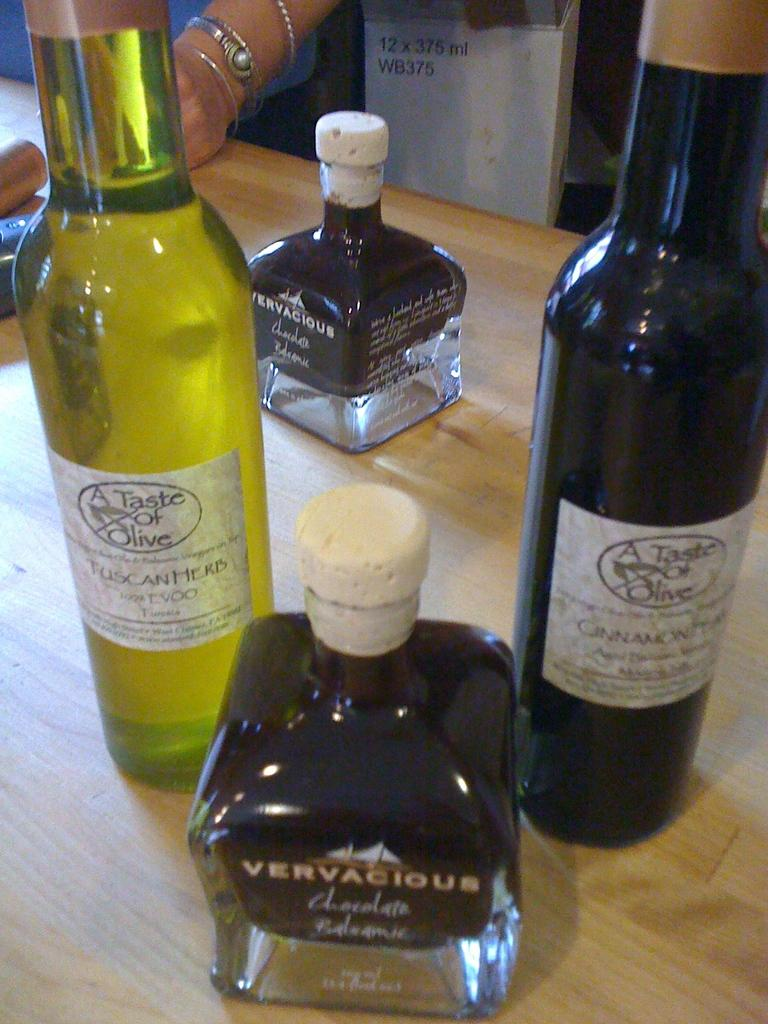<image>
Relay a brief, clear account of the picture shown. Four bottles of alcohol, including two by Taste of Olive and two by Vervacious, are arranged on a wooden table top. 